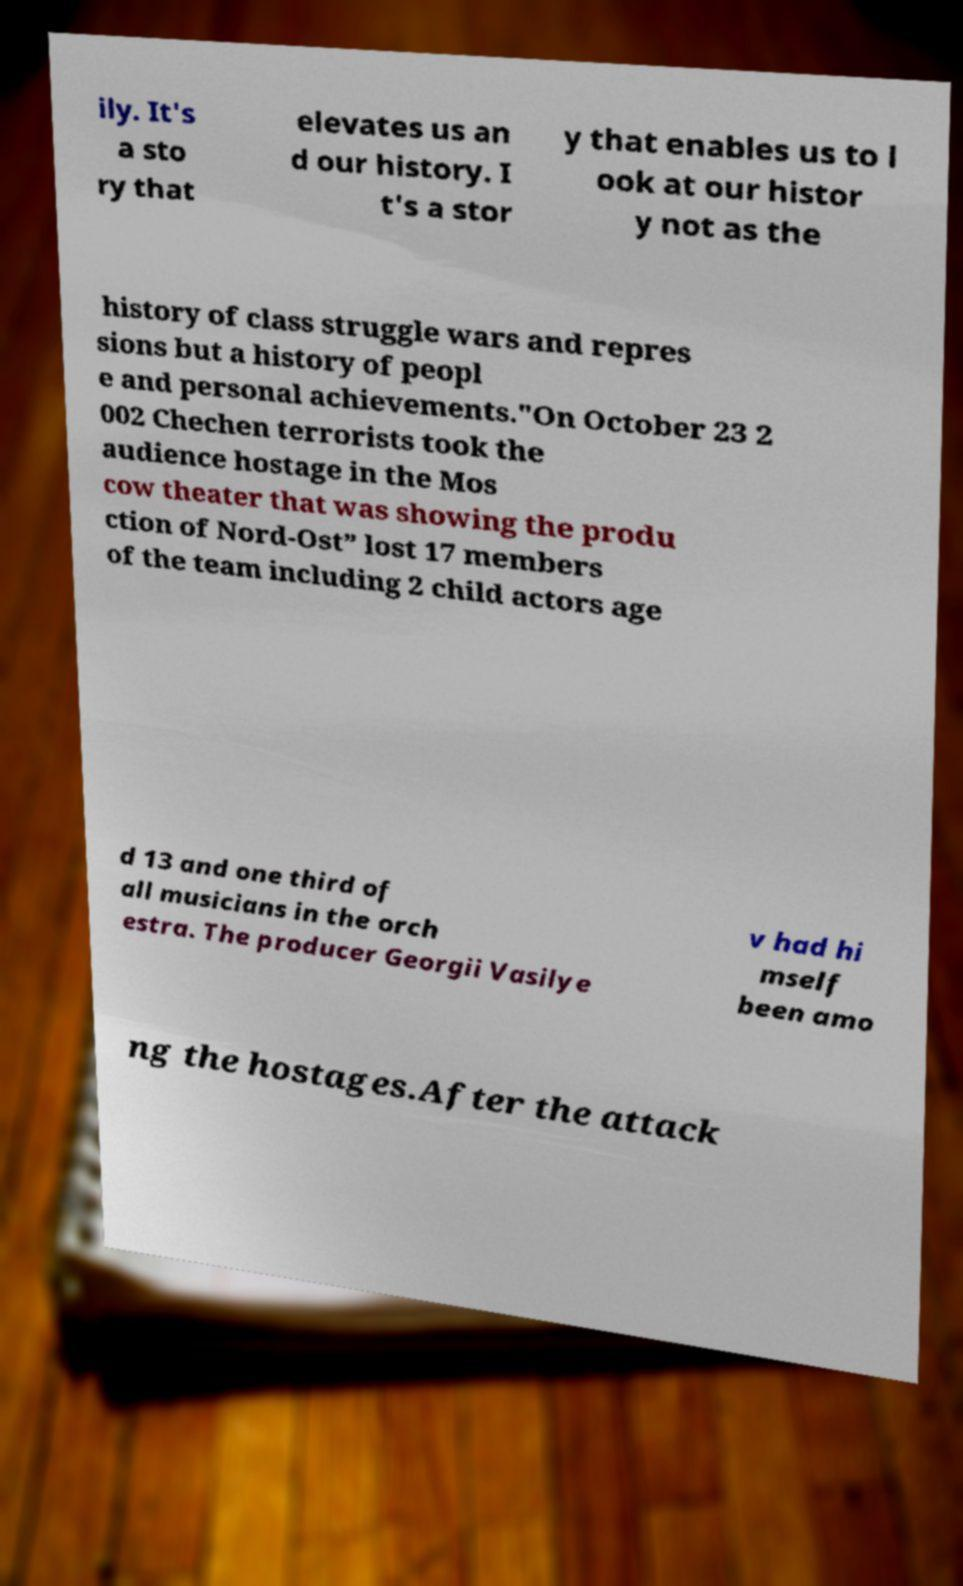Can you accurately transcribe the text from the provided image for me? ily. It's a sto ry that elevates us an d our history. I t's a stor y that enables us to l ook at our histor y not as the history of class struggle wars and repres sions but a history of peopl e and personal achievements."On October 23 2 002 Chechen terrorists took the audience hostage in the Mos cow theater that was showing the produ ction of Nord-Ost” lost 17 members of the team including 2 child actors age d 13 and one third of all musicians in the orch estra. The producer Georgii Vasilye v had hi mself been amo ng the hostages.After the attack 